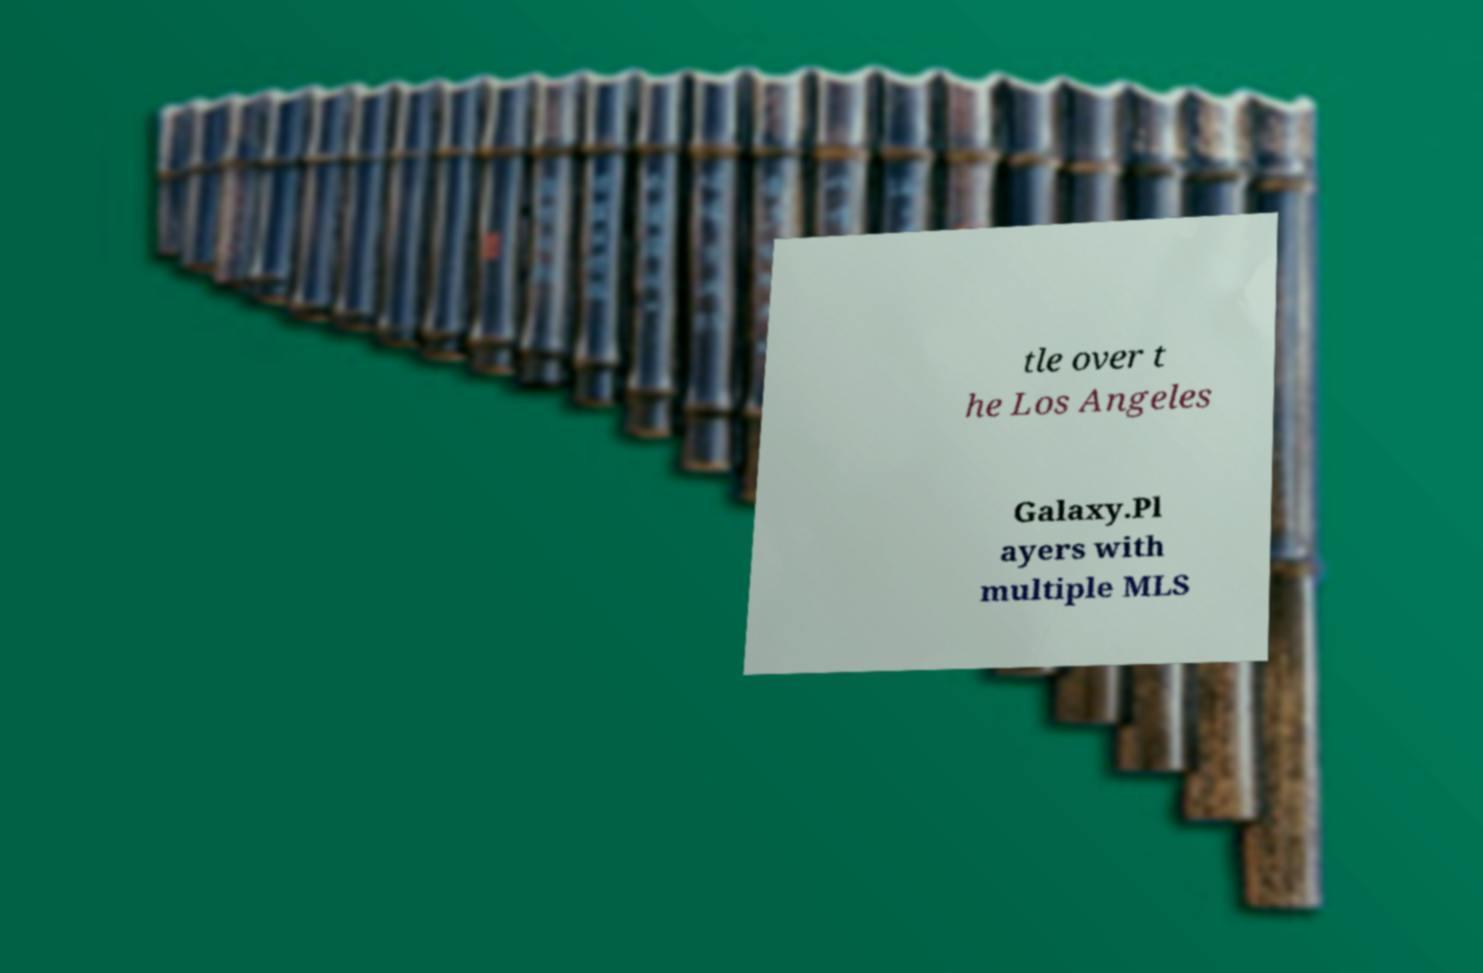Can you read and provide the text displayed in the image?This photo seems to have some interesting text. Can you extract and type it out for me? tle over t he Los Angeles Galaxy.Pl ayers with multiple MLS 